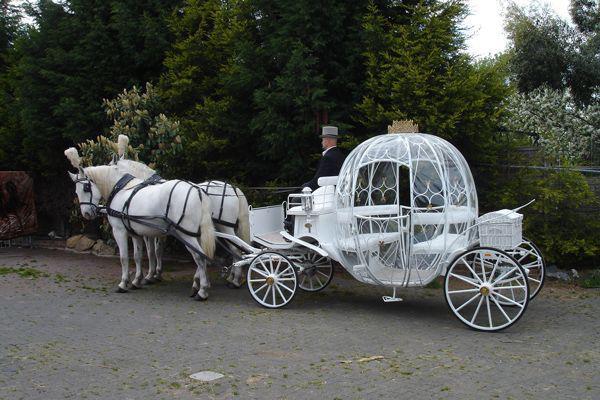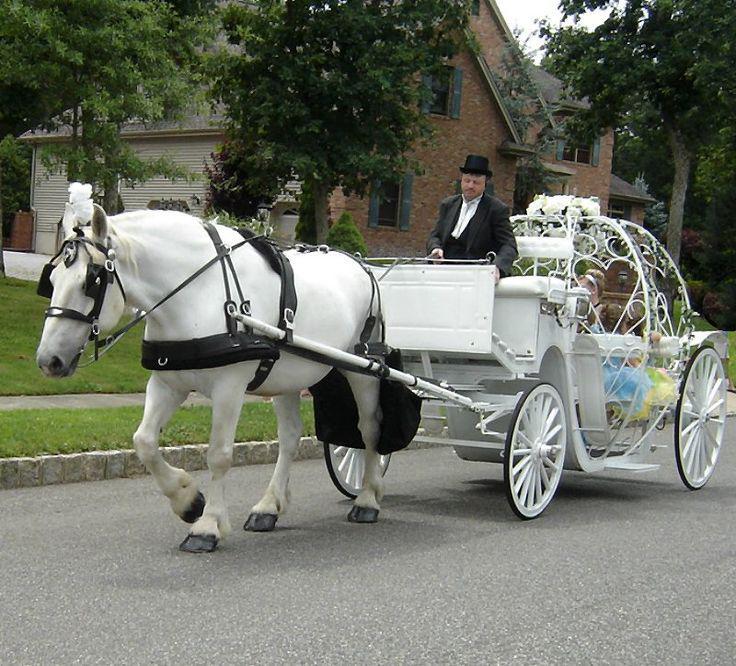The first image is the image on the left, the second image is the image on the right. For the images displayed, is the sentence "In at least one image there are two white horses pulling a white pumpkin carriage." factually correct? Answer yes or no. Yes. The first image is the image on the left, the second image is the image on the right. Assess this claim about the two images: "there are white horses with tassels on the top of their heads pulling a cinderella type princess carriage". Correct or not? Answer yes or no. Yes. 